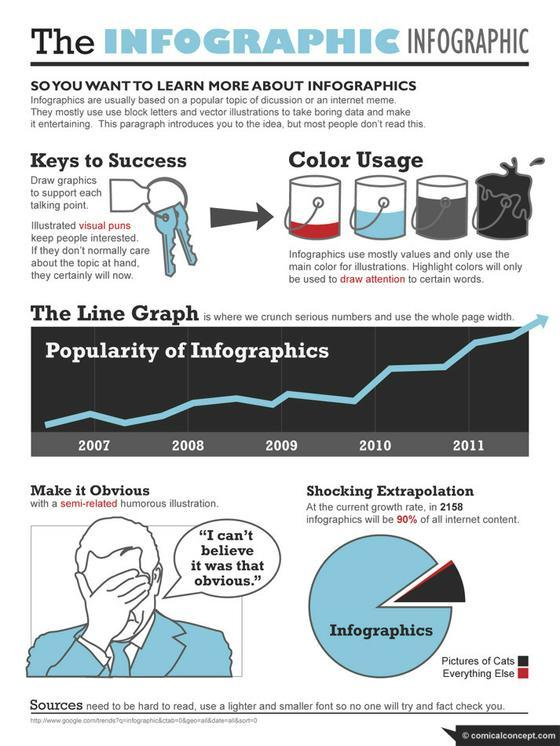How Info graphics works?
Answer the question with a short phrase. Infographics use mostly values and only use the main color for illustrations In which year Info graphics got a good reach after so many years of Ups and Downs?? 2010 At the current growth rate of Info graphics what percentage of Info graphics only will be missing from internet content in 2158 ? 10 